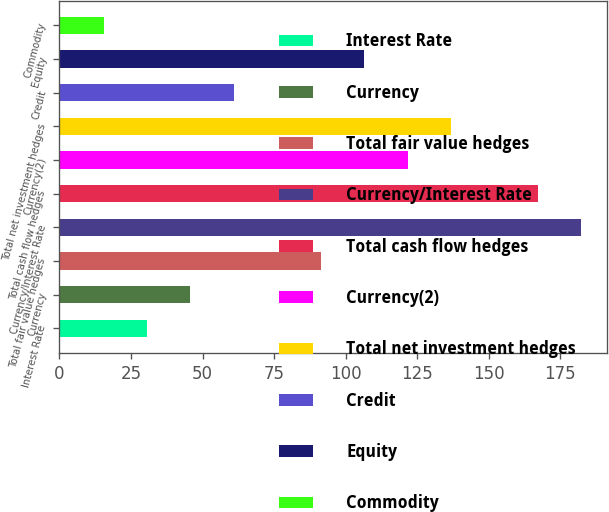Convert chart to OTSL. <chart><loc_0><loc_0><loc_500><loc_500><bar_chart><fcel>Interest Rate<fcel>Currency<fcel>Total fair value hedges<fcel>Currency/Interest Rate<fcel>Total cash flow hedges<fcel>Currency(2)<fcel>Total net investment hedges<fcel>Credit<fcel>Equity<fcel>Commodity<nl><fcel>30.62<fcel>45.79<fcel>91.3<fcel>182.32<fcel>167.15<fcel>121.64<fcel>136.81<fcel>60.96<fcel>106.47<fcel>15.45<nl></chart> 